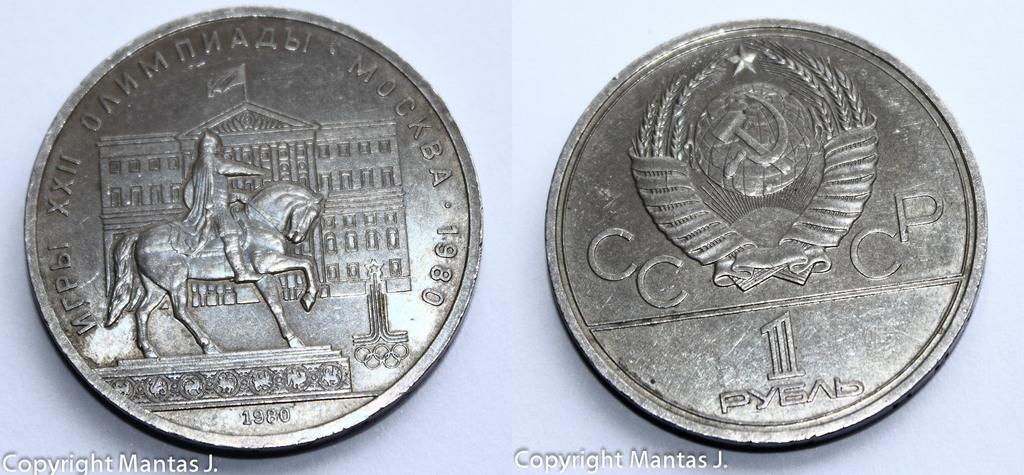<image>
Create a compact narrative representing the image presented. Two coins that are copyrighted by Mantas J. are next to each other. 